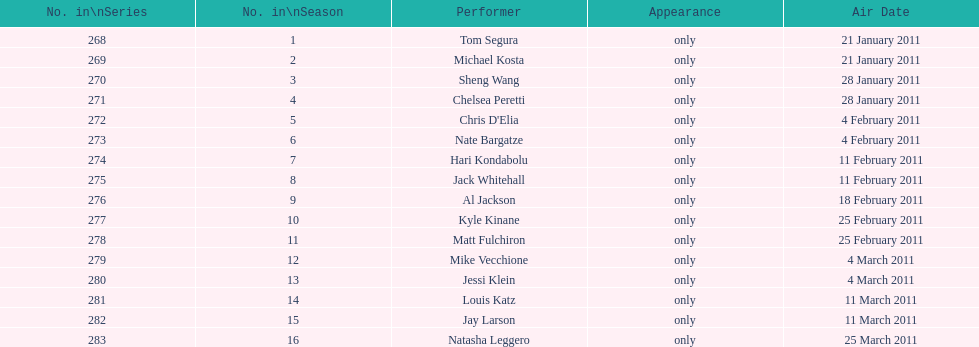Did al jackson air before or after kyle kinane? Before. 